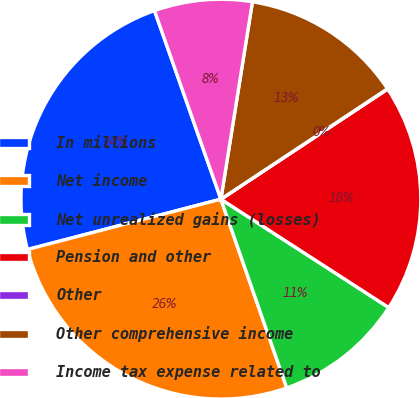Convert chart to OTSL. <chart><loc_0><loc_0><loc_500><loc_500><pie_chart><fcel>In millions<fcel>Net income<fcel>Net unrealized gains (losses)<fcel>Pension and other<fcel>Other<fcel>Other comprehensive income<fcel>Income tax expense related to<nl><fcel>23.66%<fcel>26.29%<fcel>10.53%<fcel>18.41%<fcel>0.03%<fcel>13.16%<fcel>7.91%<nl></chart> 